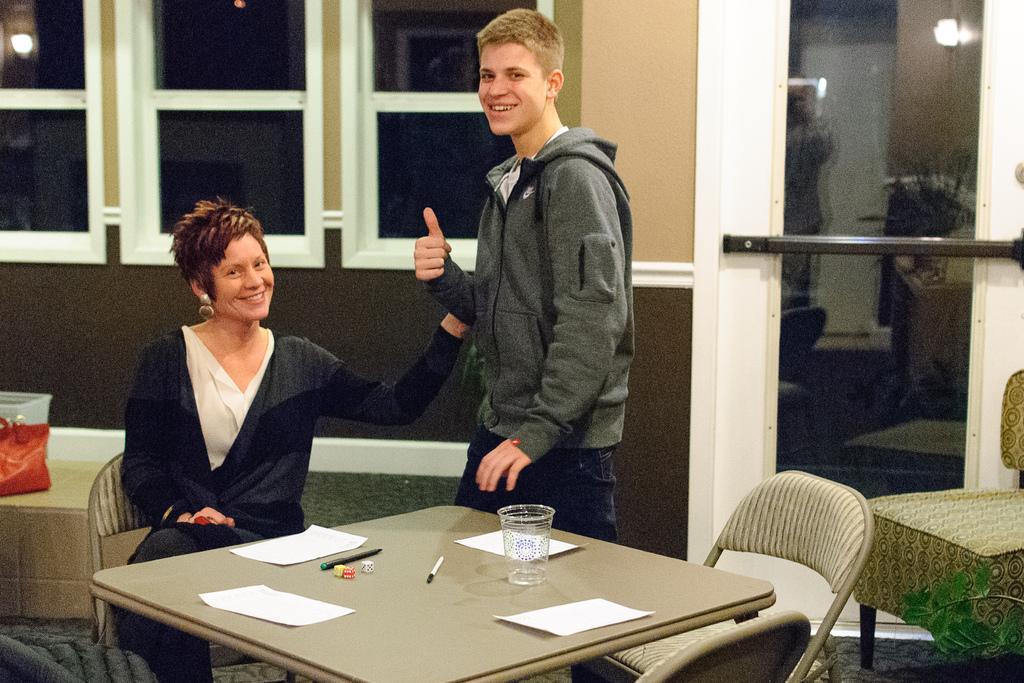Describe this image in one or two sentences. The women wearing black dress is sitting in a chair and there is a person standing beside her and there is a table in front of them which has four papers,pens,dice and a glass and there is a window in the background. 